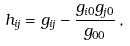Convert formula to latex. <formula><loc_0><loc_0><loc_500><loc_500>h _ { i j } = g _ { i j } - \frac { g _ { i 0 } g _ { j 0 } } { g _ { 0 0 } } \, ,</formula> 